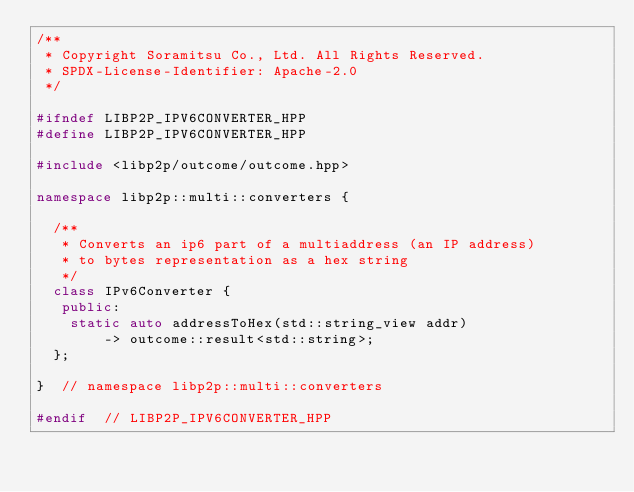Convert code to text. <code><loc_0><loc_0><loc_500><loc_500><_C++_>/**
 * Copyright Soramitsu Co., Ltd. All Rights Reserved.
 * SPDX-License-Identifier: Apache-2.0
 */

#ifndef LIBP2P_IPV6CONVERTER_HPP
#define LIBP2P_IPV6CONVERTER_HPP

#include <libp2p/outcome/outcome.hpp>

namespace libp2p::multi::converters {

  /**
   * Converts an ip6 part of a multiaddress (an IP address)
   * to bytes representation as a hex string
   */
  class IPv6Converter {
   public:
    static auto addressToHex(std::string_view addr)
        -> outcome::result<std::string>;
  };

}  // namespace libp2p::multi::converters

#endif  // LIBP2P_IPV6CONVERTER_HPP
</code> 